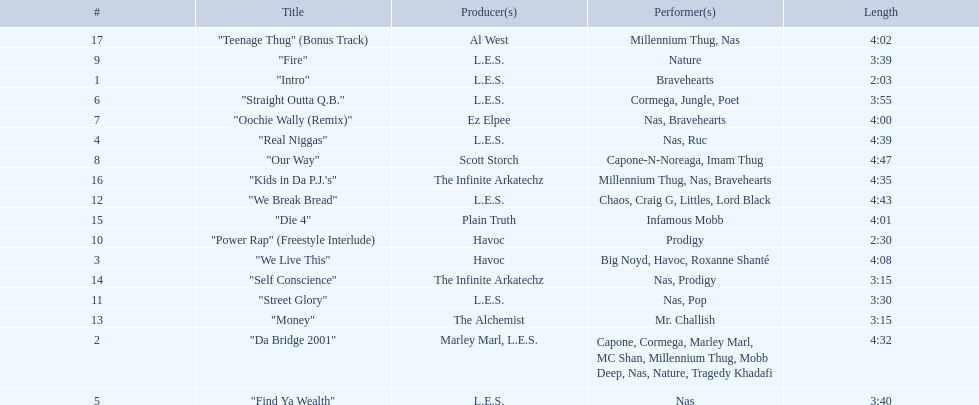What song was performed before "fire"? "Our Way". 